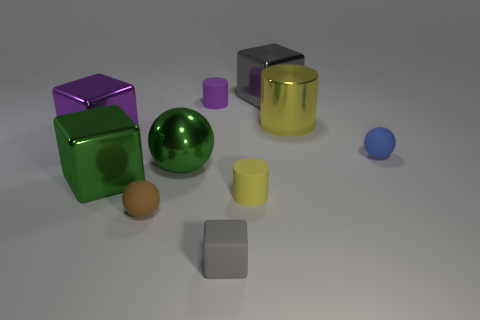Can you describe the texture of the surface on which the objects are placed? The objects are positioned on a flat surface that appears to have a slightly reflective, matte texture, enhancing the objects' visibility. 